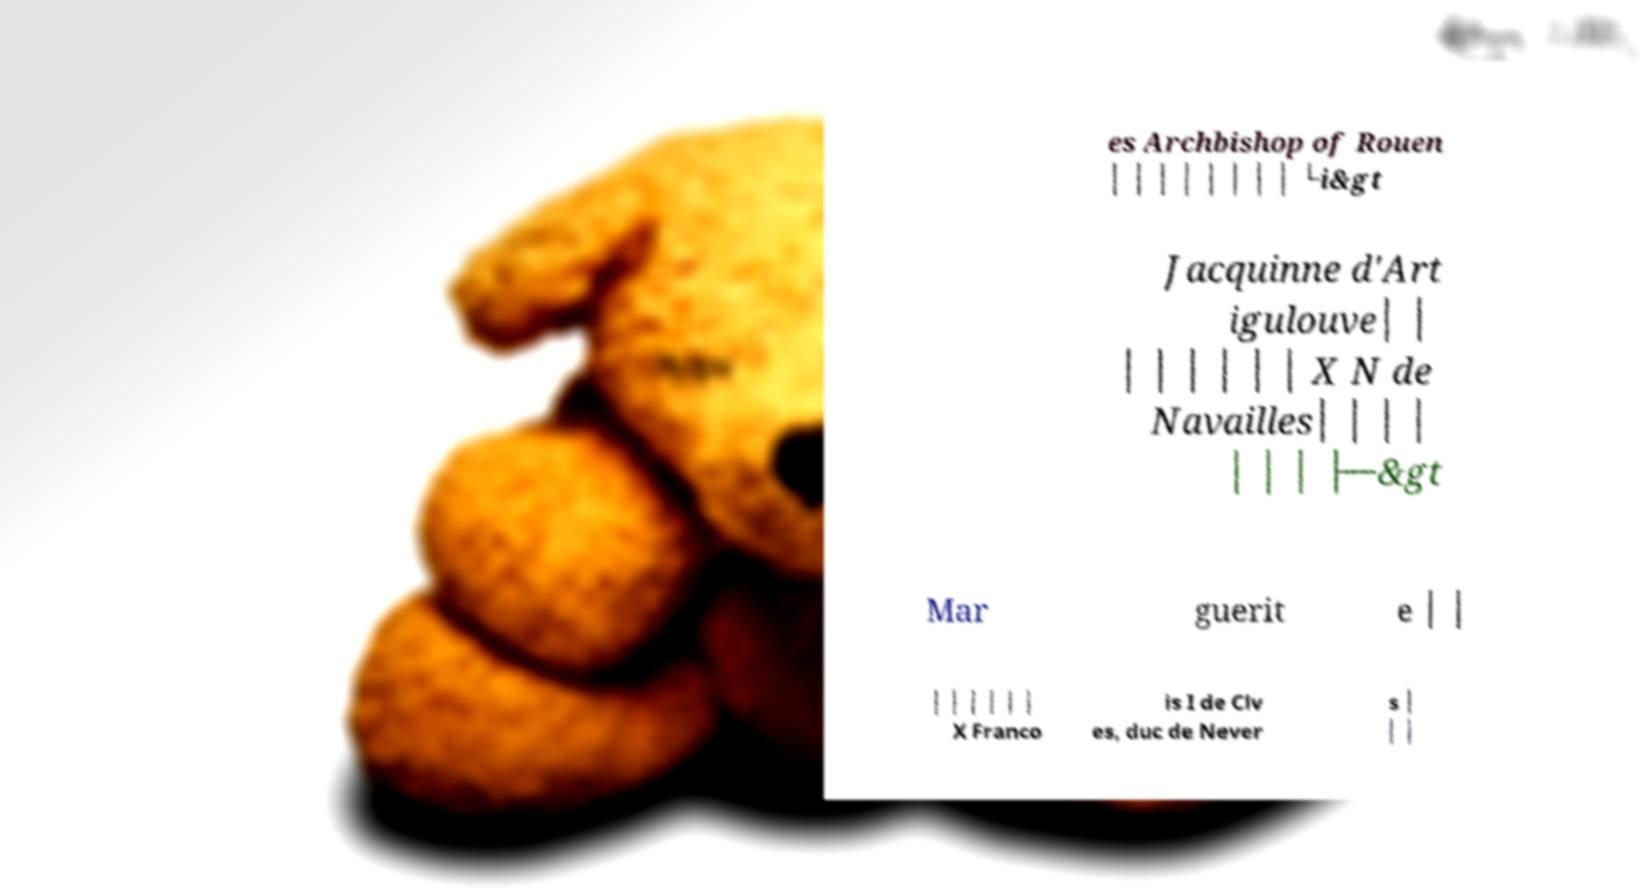Could you extract and type out the text from this image? es Archbishop of Rouen │ │ │ │ │ │ │ │ └i&gt Jacquinne d'Art igulouve│ │ │ │ │ │ │ │ X N de Navailles│ │ │ │ │ │ │ ├─&gt Mar guerit e │ │ │ │ │ │ │ │ X Franco is I de Clv es, duc de Never s │ │ │ 